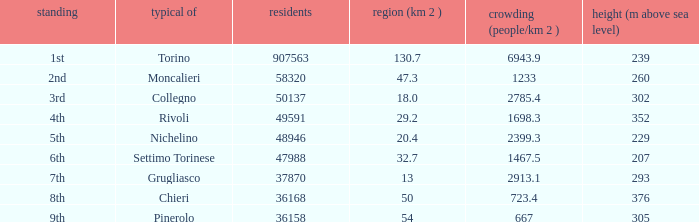What is the name of the 9th ranked common? Pinerolo. 